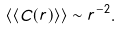Convert formula to latex. <formula><loc_0><loc_0><loc_500><loc_500>\langle \langle C ( r ) \rangle \rangle \sim r ^ { - 2 } .</formula> 